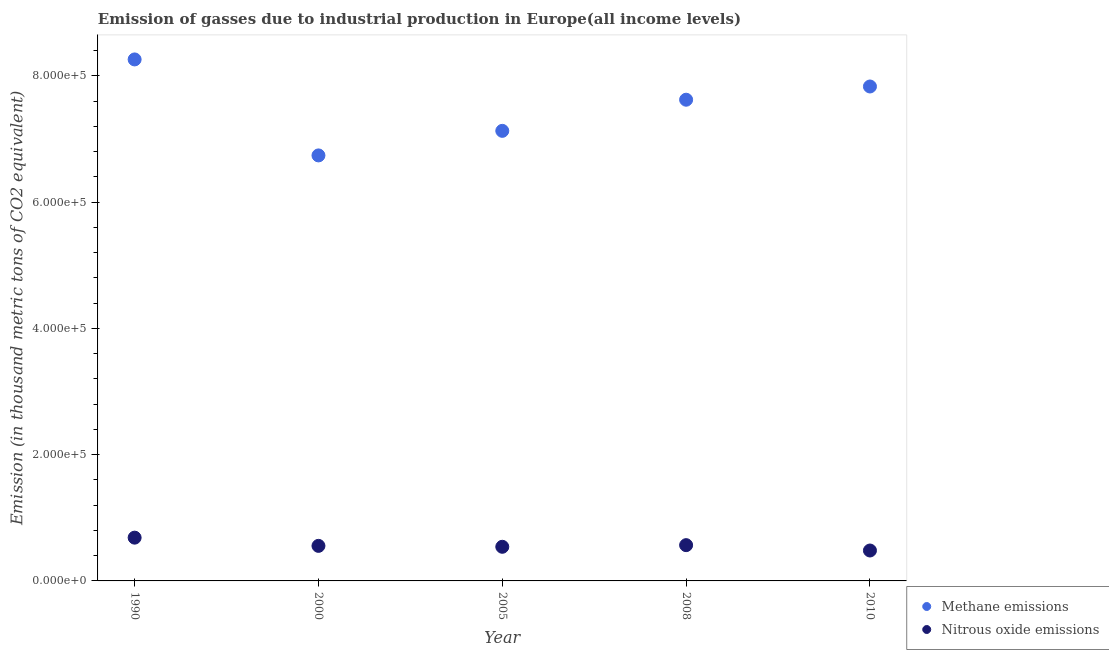How many different coloured dotlines are there?
Give a very brief answer. 2. What is the amount of nitrous oxide emissions in 1990?
Offer a very short reply. 6.86e+04. Across all years, what is the maximum amount of nitrous oxide emissions?
Offer a very short reply. 6.86e+04. Across all years, what is the minimum amount of methane emissions?
Offer a very short reply. 6.74e+05. What is the total amount of methane emissions in the graph?
Give a very brief answer. 3.76e+06. What is the difference between the amount of nitrous oxide emissions in 2000 and that in 2010?
Keep it short and to the point. 7349.4. What is the difference between the amount of nitrous oxide emissions in 2008 and the amount of methane emissions in 2005?
Offer a very short reply. -6.56e+05. What is the average amount of nitrous oxide emissions per year?
Offer a very short reply. 5.66e+04. In the year 1990, what is the difference between the amount of nitrous oxide emissions and amount of methane emissions?
Provide a succinct answer. -7.58e+05. In how many years, is the amount of methane emissions greater than 280000 thousand metric tons?
Your answer should be compact. 5. What is the ratio of the amount of nitrous oxide emissions in 2000 to that in 2010?
Ensure brevity in your answer.  1.15. Is the difference between the amount of nitrous oxide emissions in 2000 and 2005 greater than the difference between the amount of methane emissions in 2000 and 2005?
Give a very brief answer. Yes. What is the difference between the highest and the second highest amount of methane emissions?
Your answer should be very brief. 4.29e+04. What is the difference between the highest and the lowest amount of nitrous oxide emissions?
Give a very brief answer. 2.04e+04. In how many years, is the amount of nitrous oxide emissions greater than the average amount of nitrous oxide emissions taken over all years?
Offer a very short reply. 2. Does the amount of nitrous oxide emissions monotonically increase over the years?
Provide a succinct answer. No. How many dotlines are there?
Keep it short and to the point. 2. Are the values on the major ticks of Y-axis written in scientific E-notation?
Provide a succinct answer. Yes. Does the graph contain grids?
Offer a terse response. No. Where does the legend appear in the graph?
Offer a terse response. Bottom right. How many legend labels are there?
Make the answer very short. 2. What is the title of the graph?
Offer a terse response. Emission of gasses due to industrial production in Europe(all income levels). Does "Primary education" appear as one of the legend labels in the graph?
Make the answer very short. No. What is the label or title of the Y-axis?
Keep it short and to the point. Emission (in thousand metric tons of CO2 equivalent). What is the Emission (in thousand metric tons of CO2 equivalent) in Methane emissions in 1990?
Ensure brevity in your answer.  8.26e+05. What is the Emission (in thousand metric tons of CO2 equivalent) of Nitrous oxide emissions in 1990?
Keep it short and to the point. 6.86e+04. What is the Emission (in thousand metric tons of CO2 equivalent) in Methane emissions in 2000?
Your answer should be compact. 6.74e+05. What is the Emission (in thousand metric tons of CO2 equivalent) in Nitrous oxide emissions in 2000?
Offer a terse response. 5.55e+04. What is the Emission (in thousand metric tons of CO2 equivalent) of Methane emissions in 2005?
Your answer should be very brief. 7.13e+05. What is the Emission (in thousand metric tons of CO2 equivalent) in Nitrous oxide emissions in 2005?
Provide a short and direct response. 5.41e+04. What is the Emission (in thousand metric tons of CO2 equivalent) of Methane emissions in 2008?
Ensure brevity in your answer.  7.62e+05. What is the Emission (in thousand metric tons of CO2 equivalent) of Nitrous oxide emissions in 2008?
Your answer should be compact. 5.67e+04. What is the Emission (in thousand metric tons of CO2 equivalent) in Methane emissions in 2010?
Your answer should be compact. 7.83e+05. What is the Emission (in thousand metric tons of CO2 equivalent) of Nitrous oxide emissions in 2010?
Your response must be concise. 4.82e+04. Across all years, what is the maximum Emission (in thousand metric tons of CO2 equivalent) in Methane emissions?
Offer a terse response. 8.26e+05. Across all years, what is the maximum Emission (in thousand metric tons of CO2 equivalent) in Nitrous oxide emissions?
Your answer should be compact. 6.86e+04. Across all years, what is the minimum Emission (in thousand metric tons of CO2 equivalent) of Methane emissions?
Make the answer very short. 6.74e+05. Across all years, what is the minimum Emission (in thousand metric tons of CO2 equivalent) in Nitrous oxide emissions?
Offer a terse response. 4.82e+04. What is the total Emission (in thousand metric tons of CO2 equivalent) in Methane emissions in the graph?
Your answer should be very brief. 3.76e+06. What is the total Emission (in thousand metric tons of CO2 equivalent) in Nitrous oxide emissions in the graph?
Your response must be concise. 2.83e+05. What is the difference between the Emission (in thousand metric tons of CO2 equivalent) in Methane emissions in 1990 and that in 2000?
Ensure brevity in your answer.  1.52e+05. What is the difference between the Emission (in thousand metric tons of CO2 equivalent) of Nitrous oxide emissions in 1990 and that in 2000?
Offer a very short reply. 1.30e+04. What is the difference between the Emission (in thousand metric tons of CO2 equivalent) of Methane emissions in 1990 and that in 2005?
Your answer should be compact. 1.13e+05. What is the difference between the Emission (in thousand metric tons of CO2 equivalent) in Nitrous oxide emissions in 1990 and that in 2005?
Offer a terse response. 1.45e+04. What is the difference between the Emission (in thousand metric tons of CO2 equivalent) in Methane emissions in 1990 and that in 2008?
Keep it short and to the point. 6.38e+04. What is the difference between the Emission (in thousand metric tons of CO2 equivalent) in Nitrous oxide emissions in 1990 and that in 2008?
Give a very brief answer. 1.19e+04. What is the difference between the Emission (in thousand metric tons of CO2 equivalent) of Methane emissions in 1990 and that in 2010?
Provide a succinct answer. 4.29e+04. What is the difference between the Emission (in thousand metric tons of CO2 equivalent) in Nitrous oxide emissions in 1990 and that in 2010?
Offer a very short reply. 2.04e+04. What is the difference between the Emission (in thousand metric tons of CO2 equivalent) of Methane emissions in 2000 and that in 2005?
Ensure brevity in your answer.  -3.89e+04. What is the difference between the Emission (in thousand metric tons of CO2 equivalent) of Nitrous oxide emissions in 2000 and that in 2005?
Provide a short and direct response. 1458.2. What is the difference between the Emission (in thousand metric tons of CO2 equivalent) in Methane emissions in 2000 and that in 2008?
Your answer should be compact. -8.82e+04. What is the difference between the Emission (in thousand metric tons of CO2 equivalent) in Nitrous oxide emissions in 2000 and that in 2008?
Provide a succinct answer. -1145.4. What is the difference between the Emission (in thousand metric tons of CO2 equivalent) of Methane emissions in 2000 and that in 2010?
Your answer should be very brief. -1.09e+05. What is the difference between the Emission (in thousand metric tons of CO2 equivalent) in Nitrous oxide emissions in 2000 and that in 2010?
Provide a short and direct response. 7349.4. What is the difference between the Emission (in thousand metric tons of CO2 equivalent) in Methane emissions in 2005 and that in 2008?
Provide a short and direct response. -4.93e+04. What is the difference between the Emission (in thousand metric tons of CO2 equivalent) in Nitrous oxide emissions in 2005 and that in 2008?
Offer a very short reply. -2603.6. What is the difference between the Emission (in thousand metric tons of CO2 equivalent) of Methane emissions in 2005 and that in 2010?
Ensure brevity in your answer.  -7.03e+04. What is the difference between the Emission (in thousand metric tons of CO2 equivalent) of Nitrous oxide emissions in 2005 and that in 2010?
Offer a terse response. 5891.2. What is the difference between the Emission (in thousand metric tons of CO2 equivalent) of Methane emissions in 2008 and that in 2010?
Provide a short and direct response. -2.10e+04. What is the difference between the Emission (in thousand metric tons of CO2 equivalent) in Nitrous oxide emissions in 2008 and that in 2010?
Make the answer very short. 8494.8. What is the difference between the Emission (in thousand metric tons of CO2 equivalent) in Methane emissions in 1990 and the Emission (in thousand metric tons of CO2 equivalent) in Nitrous oxide emissions in 2000?
Your response must be concise. 7.71e+05. What is the difference between the Emission (in thousand metric tons of CO2 equivalent) of Methane emissions in 1990 and the Emission (in thousand metric tons of CO2 equivalent) of Nitrous oxide emissions in 2005?
Your response must be concise. 7.72e+05. What is the difference between the Emission (in thousand metric tons of CO2 equivalent) of Methane emissions in 1990 and the Emission (in thousand metric tons of CO2 equivalent) of Nitrous oxide emissions in 2008?
Give a very brief answer. 7.70e+05. What is the difference between the Emission (in thousand metric tons of CO2 equivalent) in Methane emissions in 1990 and the Emission (in thousand metric tons of CO2 equivalent) in Nitrous oxide emissions in 2010?
Provide a succinct answer. 7.78e+05. What is the difference between the Emission (in thousand metric tons of CO2 equivalent) of Methane emissions in 2000 and the Emission (in thousand metric tons of CO2 equivalent) of Nitrous oxide emissions in 2005?
Keep it short and to the point. 6.20e+05. What is the difference between the Emission (in thousand metric tons of CO2 equivalent) of Methane emissions in 2000 and the Emission (in thousand metric tons of CO2 equivalent) of Nitrous oxide emissions in 2008?
Provide a succinct answer. 6.17e+05. What is the difference between the Emission (in thousand metric tons of CO2 equivalent) of Methane emissions in 2000 and the Emission (in thousand metric tons of CO2 equivalent) of Nitrous oxide emissions in 2010?
Provide a short and direct response. 6.26e+05. What is the difference between the Emission (in thousand metric tons of CO2 equivalent) in Methane emissions in 2005 and the Emission (in thousand metric tons of CO2 equivalent) in Nitrous oxide emissions in 2008?
Make the answer very short. 6.56e+05. What is the difference between the Emission (in thousand metric tons of CO2 equivalent) in Methane emissions in 2005 and the Emission (in thousand metric tons of CO2 equivalent) in Nitrous oxide emissions in 2010?
Offer a terse response. 6.65e+05. What is the difference between the Emission (in thousand metric tons of CO2 equivalent) of Methane emissions in 2008 and the Emission (in thousand metric tons of CO2 equivalent) of Nitrous oxide emissions in 2010?
Your answer should be very brief. 7.14e+05. What is the average Emission (in thousand metric tons of CO2 equivalent) in Methane emissions per year?
Keep it short and to the point. 7.52e+05. What is the average Emission (in thousand metric tons of CO2 equivalent) of Nitrous oxide emissions per year?
Keep it short and to the point. 5.66e+04. In the year 1990, what is the difference between the Emission (in thousand metric tons of CO2 equivalent) in Methane emissions and Emission (in thousand metric tons of CO2 equivalent) in Nitrous oxide emissions?
Make the answer very short. 7.58e+05. In the year 2000, what is the difference between the Emission (in thousand metric tons of CO2 equivalent) in Methane emissions and Emission (in thousand metric tons of CO2 equivalent) in Nitrous oxide emissions?
Your answer should be compact. 6.19e+05. In the year 2005, what is the difference between the Emission (in thousand metric tons of CO2 equivalent) in Methane emissions and Emission (in thousand metric tons of CO2 equivalent) in Nitrous oxide emissions?
Your answer should be compact. 6.59e+05. In the year 2008, what is the difference between the Emission (in thousand metric tons of CO2 equivalent) in Methane emissions and Emission (in thousand metric tons of CO2 equivalent) in Nitrous oxide emissions?
Make the answer very short. 7.06e+05. In the year 2010, what is the difference between the Emission (in thousand metric tons of CO2 equivalent) in Methane emissions and Emission (in thousand metric tons of CO2 equivalent) in Nitrous oxide emissions?
Your answer should be compact. 7.35e+05. What is the ratio of the Emission (in thousand metric tons of CO2 equivalent) of Methane emissions in 1990 to that in 2000?
Offer a very short reply. 1.23. What is the ratio of the Emission (in thousand metric tons of CO2 equivalent) of Nitrous oxide emissions in 1990 to that in 2000?
Offer a terse response. 1.23. What is the ratio of the Emission (in thousand metric tons of CO2 equivalent) of Methane emissions in 1990 to that in 2005?
Your answer should be very brief. 1.16. What is the ratio of the Emission (in thousand metric tons of CO2 equivalent) in Nitrous oxide emissions in 1990 to that in 2005?
Give a very brief answer. 1.27. What is the ratio of the Emission (in thousand metric tons of CO2 equivalent) of Methane emissions in 1990 to that in 2008?
Keep it short and to the point. 1.08. What is the ratio of the Emission (in thousand metric tons of CO2 equivalent) of Nitrous oxide emissions in 1990 to that in 2008?
Offer a very short reply. 1.21. What is the ratio of the Emission (in thousand metric tons of CO2 equivalent) in Methane emissions in 1990 to that in 2010?
Offer a terse response. 1.05. What is the ratio of the Emission (in thousand metric tons of CO2 equivalent) of Nitrous oxide emissions in 1990 to that in 2010?
Your answer should be very brief. 1.42. What is the ratio of the Emission (in thousand metric tons of CO2 equivalent) of Methane emissions in 2000 to that in 2005?
Your answer should be compact. 0.95. What is the ratio of the Emission (in thousand metric tons of CO2 equivalent) of Nitrous oxide emissions in 2000 to that in 2005?
Your response must be concise. 1.03. What is the ratio of the Emission (in thousand metric tons of CO2 equivalent) in Methane emissions in 2000 to that in 2008?
Ensure brevity in your answer.  0.88. What is the ratio of the Emission (in thousand metric tons of CO2 equivalent) of Nitrous oxide emissions in 2000 to that in 2008?
Keep it short and to the point. 0.98. What is the ratio of the Emission (in thousand metric tons of CO2 equivalent) in Methane emissions in 2000 to that in 2010?
Offer a terse response. 0.86. What is the ratio of the Emission (in thousand metric tons of CO2 equivalent) of Nitrous oxide emissions in 2000 to that in 2010?
Your response must be concise. 1.15. What is the ratio of the Emission (in thousand metric tons of CO2 equivalent) in Methane emissions in 2005 to that in 2008?
Your response must be concise. 0.94. What is the ratio of the Emission (in thousand metric tons of CO2 equivalent) of Nitrous oxide emissions in 2005 to that in 2008?
Ensure brevity in your answer.  0.95. What is the ratio of the Emission (in thousand metric tons of CO2 equivalent) of Methane emissions in 2005 to that in 2010?
Give a very brief answer. 0.91. What is the ratio of the Emission (in thousand metric tons of CO2 equivalent) in Nitrous oxide emissions in 2005 to that in 2010?
Your answer should be compact. 1.12. What is the ratio of the Emission (in thousand metric tons of CO2 equivalent) in Methane emissions in 2008 to that in 2010?
Your answer should be compact. 0.97. What is the ratio of the Emission (in thousand metric tons of CO2 equivalent) of Nitrous oxide emissions in 2008 to that in 2010?
Your answer should be compact. 1.18. What is the difference between the highest and the second highest Emission (in thousand metric tons of CO2 equivalent) in Methane emissions?
Ensure brevity in your answer.  4.29e+04. What is the difference between the highest and the second highest Emission (in thousand metric tons of CO2 equivalent) in Nitrous oxide emissions?
Offer a very short reply. 1.19e+04. What is the difference between the highest and the lowest Emission (in thousand metric tons of CO2 equivalent) of Methane emissions?
Offer a terse response. 1.52e+05. What is the difference between the highest and the lowest Emission (in thousand metric tons of CO2 equivalent) of Nitrous oxide emissions?
Offer a very short reply. 2.04e+04. 